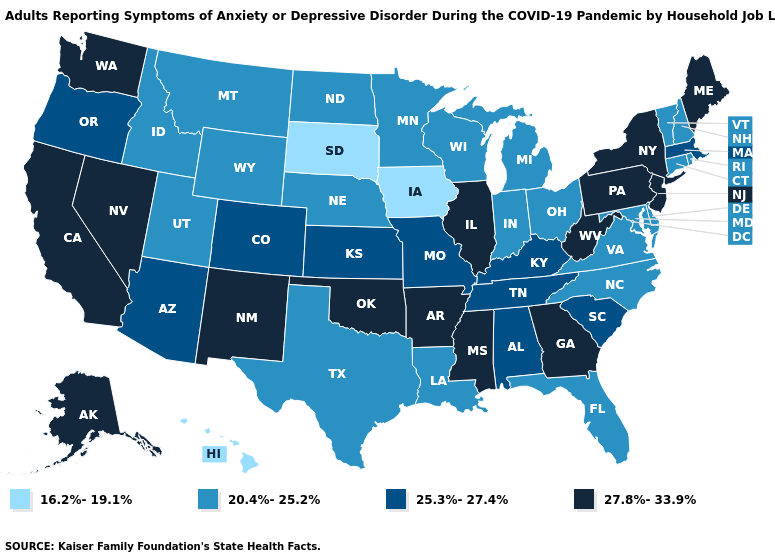Does New Mexico have a higher value than New Jersey?
Answer briefly. No. Which states hav the highest value in the West?
Write a very short answer. Alaska, California, Nevada, New Mexico, Washington. What is the value of Maryland?
Concise answer only. 20.4%-25.2%. Which states have the lowest value in the USA?
Be succinct. Hawaii, Iowa, South Dakota. Name the states that have a value in the range 20.4%-25.2%?
Be succinct. Connecticut, Delaware, Florida, Idaho, Indiana, Louisiana, Maryland, Michigan, Minnesota, Montana, Nebraska, New Hampshire, North Carolina, North Dakota, Ohio, Rhode Island, Texas, Utah, Vermont, Virginia, Wisconsin, Wyoming. Name the states that have a value in the range 16.2%-19.1%?
Quick response, please. Hawaii, Iowa, South Dakota. Name the states that have a value in the range 16.2%-19.1%?
Concise answer only. Hawaii, Iowa, South Dakota. Which states have the highest value in the USA?
Be succinct. Alaska, Arkansas, California, Georgia, Illinois, Maine, Mississippi, Nevada, New Jersey, New Mexico, New York, Oklahoma, Pennsylvania, Washington, West Virginia. What is the value of Mississippi?
Quick response, please. 27.8%-33.9%. Which states have the lowest value in the West?
Short answer required. Hawaii. What is the value of Massachusetts?
Keep it brief. 25.3%-27.4%. Does Massachusetts have the same value as Colorado?
Give a very brief answer. Yes. What is the highest value in the USA?
Concise answer only. 27.8%-33.9%. What is the value of New Jersey?
Answer briefly. 27.8%-33.9%. Which states have the lowest value in the USA?
Be succinct. Hawaii, Iowa, South Dakota. 